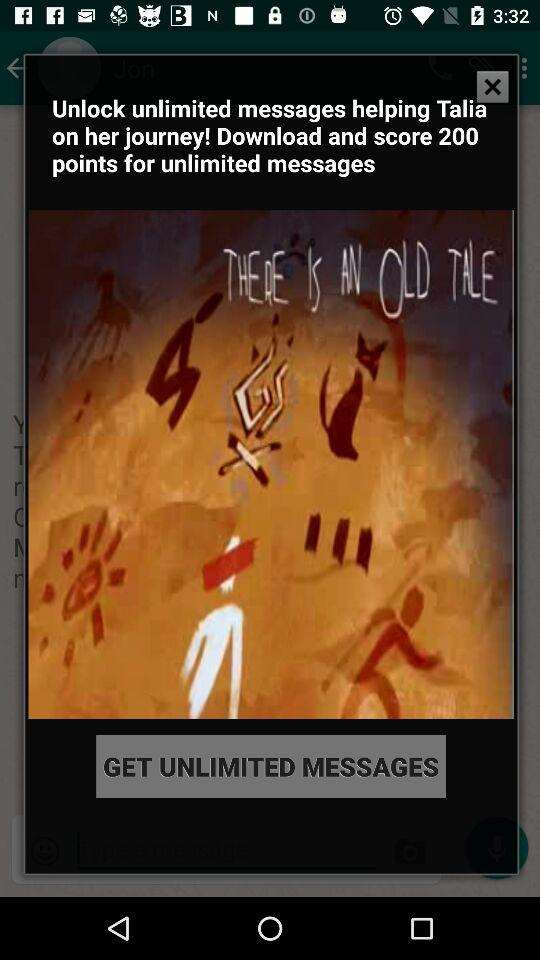How many points can you score for unlimited messages? You can score 200 points. 